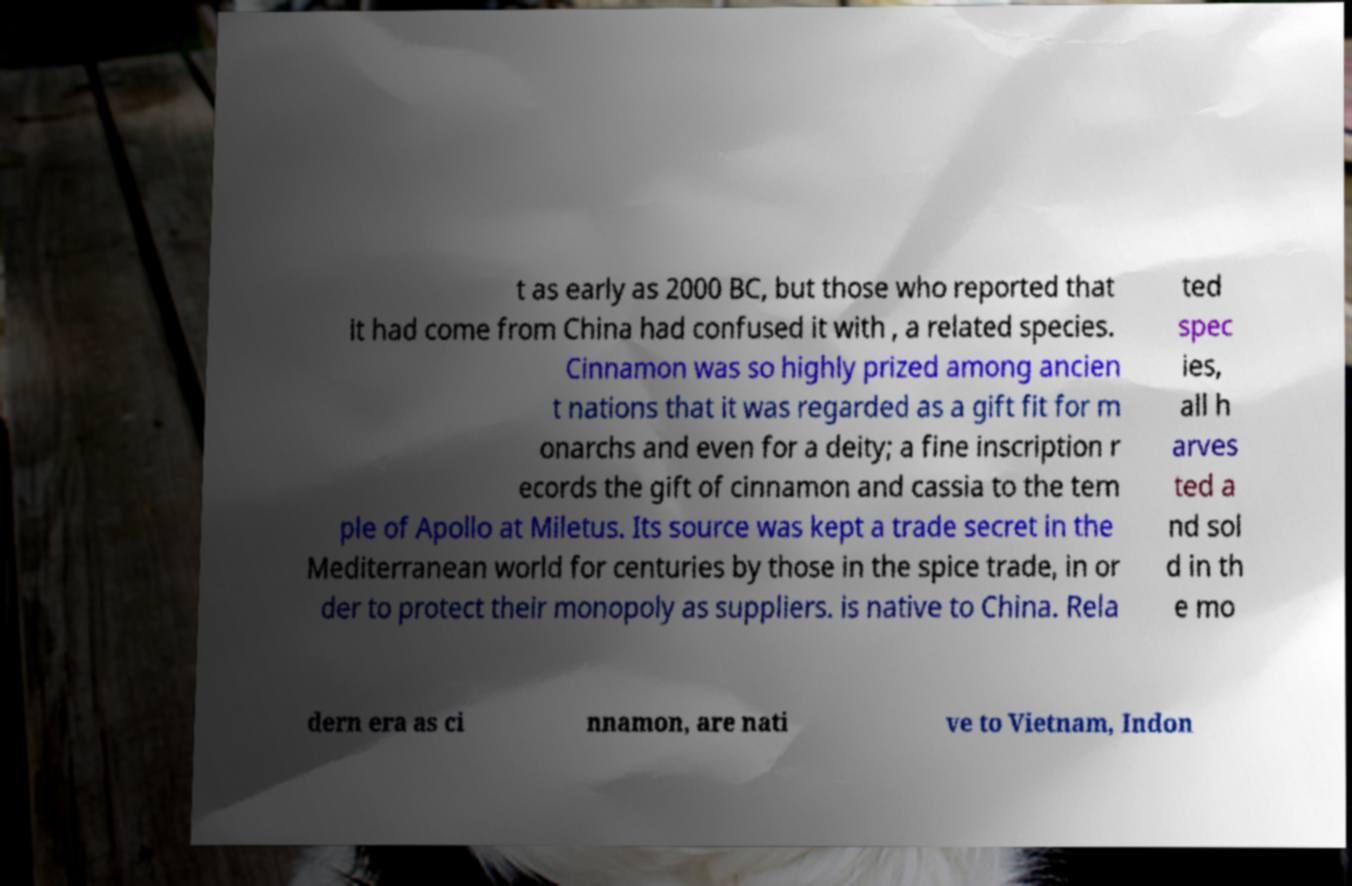Can you accurately transcribe the text from the provided image for me? t as early as 2000 BC, but those who reported that it had come from China had confused it with , a related species. Cinnamon was so highly prized among ancien t nations that it was regarded as a gift fit for m onarchs and even for a deity; a fine inscription r ecords the gift of cinnamon and cassia to the tem ple of Apollo at Miletus. Its source was kept a trade secret in the Mediterranean world for centuries by those in the spice trade, in or der to protect their monopoly as suppliers. is native to China. Rela ted spec ies, all h arves ted a nd sol d in th e mo dern era as ci nnamon, are nati ve to Vietnam, Indon 